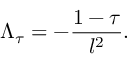Convert formula to latex. <formula><loc_0><loc_0><loc_500><loc_500>\Lambda _ { \tau } = - { \frac { 1 - \tau } { l ^ { 2 } } } .</formula> 